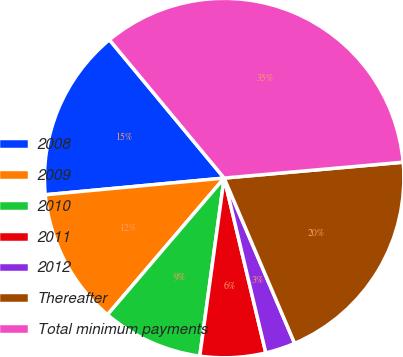Convert chart to OTSL. <chart><loc_0><loc_0><loc_500><loc_500><pie_chart><fcel>2008<fcel>2009<fcel>2010<fcel>2011<fcel>2012<fcel>Thereafter<fcel>Total minimum payments<nl><fcel>15.46%<fcel>12.27%<fcel>9.08%<fcel>5.89%<fcel>2.69%<fcel>19.99%<fcel>34.61%<nl></chart> 